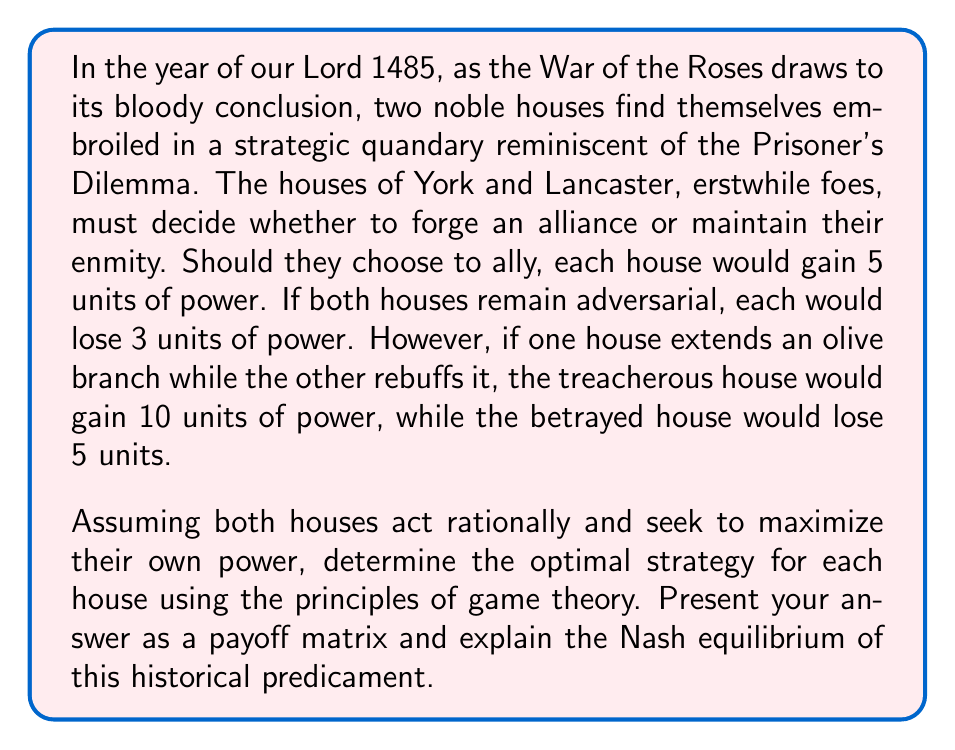Teach me how to tackle this problem. To solve this historical Prisoner's Dilemma, we shall first construct a payoff matrix to visualize the outcomes for each possible combination of strategies. Let us denote the payoffs as (York, Lancaster).

$$
\begin{array}{c|c|c}
 & \text{Lancaster Allies} & \text{Lancaster Betrays} \\
\hline
\text{York Allies} & (5, 5) & (-5, 10) \\
\hline
\text{York Betrays} & (10, -5) & (-3, -3)
\end{array}
$$

Now, let us analyze the strategic options for each house:

1. York's perspective:
   - If Lancaster allies, York gains more by betraying (10 > 5)
   - If Lancaster betrays, York loses less by betraying (-3 > -5)

2. Lancaster's perspective:
   - If York allies, Lancaster gains more by betraying (10 > 5)
   - If York betrays, Lancaster loses less by betraying (-3 > -5)

In this scenario, betrayal is the dominant strategy for both houses, as it yields a better outcome regardless of the other's choice. This leads us to the Nash equilibrium of (Betray, Betray), resulting in both houses losing 3 units of power.

The Nash equilibrium is a solution concept where no player can unilaterally improve their outcome by changing only their own strategy. In this case, if either house were to unilaterally switch to alliance, they would lose 5 units instead of 3, thus making the (Betray, Betray) outcome stable.

Paradoxically, this equilibrium is suboptimal compared to the mutual alliance outcome (5, 5). This illustrates the central tension in the Prisoner's Dilemma: individual rationality leads to a collectively inferior result.

In the context of our historical setting, this game-theoretic analysis suggests that the houses of York and Lancaster, acting in their own self-interest, would be inclined to maintain their enmity rather than form an alliance, even though cooperation would yield a better outcome for both.
Answer: The optimal strategy for each house in this historical Prisoner's Dilemma is to betray the other. The Nash equilibrium of the game is (Betray, Betray), resulting in both houses losing 3 units of power, represented as (-3, -3) in the payoff matrix. 